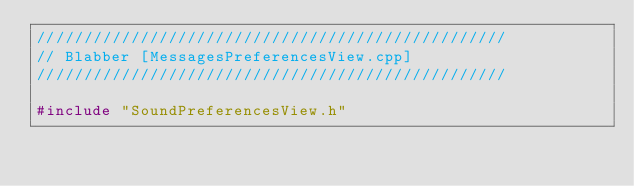Convert code to text. <code><loc_0><loc_0><loc_500><loc_500><_C++_>//////////////////////////////////////////////////
// Blabber [MessagesPreferencesView.cpp]
//////////////////////////////////////////////////

#include "SoundPreferencesView.h"
</code> 